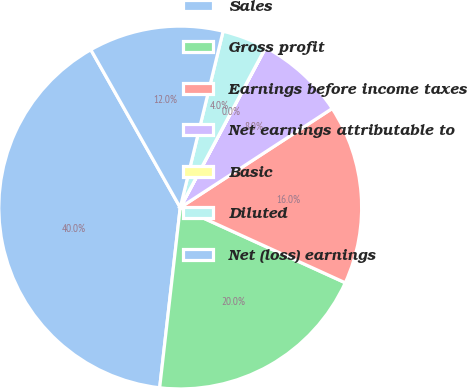Convert chart to OTSL. <chart><loc_0><loc_0><loc_500><loc_500><pie_chart><fcel>Sales<fcel>Gross profit<fcel>Earnings before income taxes<fcel>Net earnings attributable to<fcel>Basic<fcel>Diluted<fcel>Net (loss) earnings<nl><fcel>39.99%<fcel>20.0%<fcel>16.0%<fcel>8.0%<fcel>0.01%<fcel>4.0%<fcel>12.0%<nl></chart> 